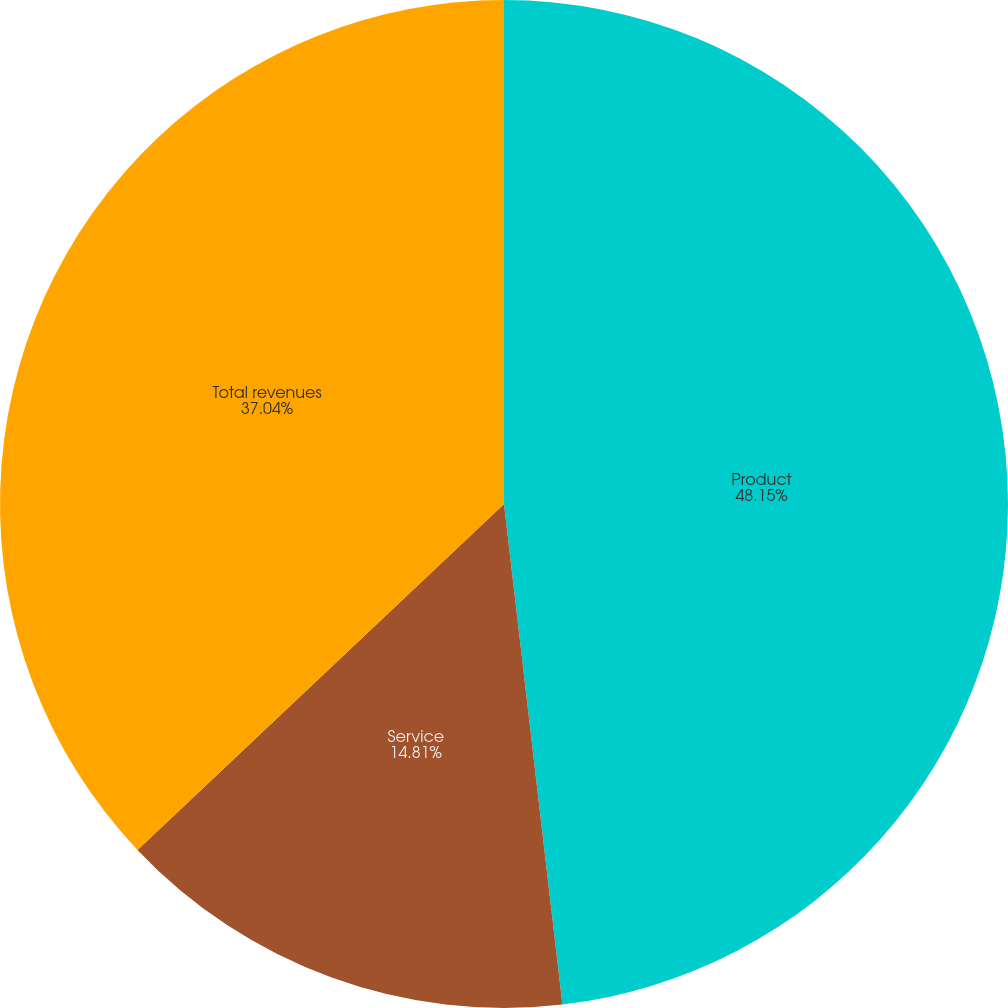Convert chart to OTSL. <chart><loc_0><loc_0><loc_500><loc_500><pie_chart><fcel>Product<fcel>Service<fcel>Total revenues<nl><fcel>48.15%<fcel>14.81%<fcel>37.04%<nl></chart> 